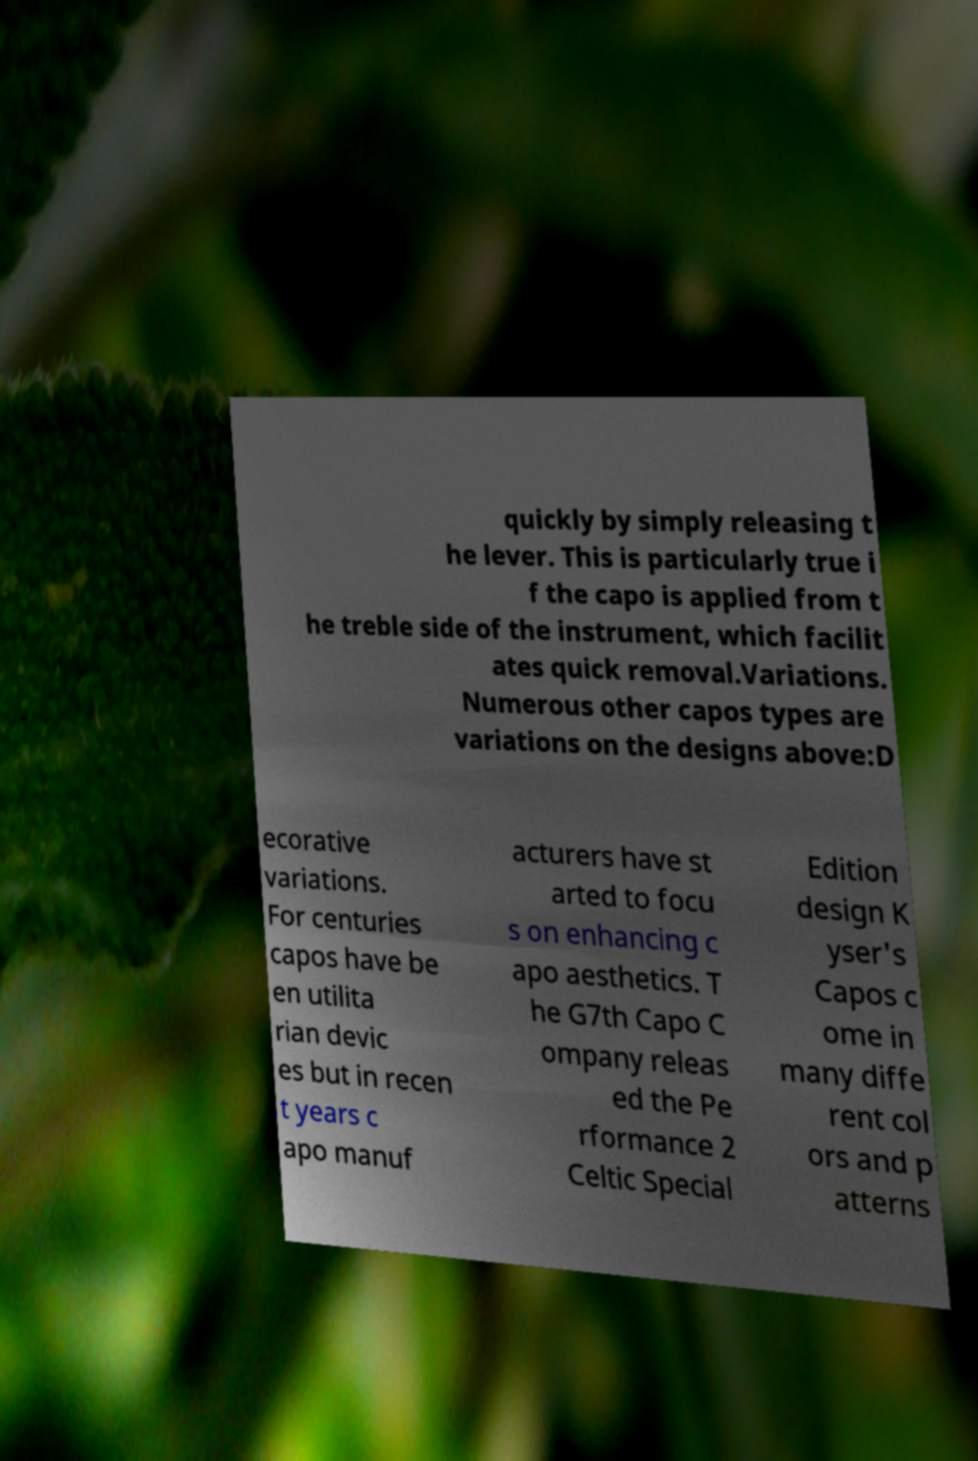Can you read and provide the text displayed in the image?This photo seems to have some interesting text. Can you extract and type it out for me? quickly by simply releasing t he lever. This is particularly true i f the capo is applied from t he treble side of the instrument, which facilit ates quick removal.Variations. Numerous other capos types are variations on the designs above:D ecorative variations. For centuries capos have be en utilita rian devic es but in recen t years c apo manuf acturers have st arted to focu s on enhancing c apo aesthetics. T he G7th Capo C ompany releas ed the Pe rformance 2 Celtic Special Edition design K yser's Capos c ome in many diffe rent col ors and p atterns 